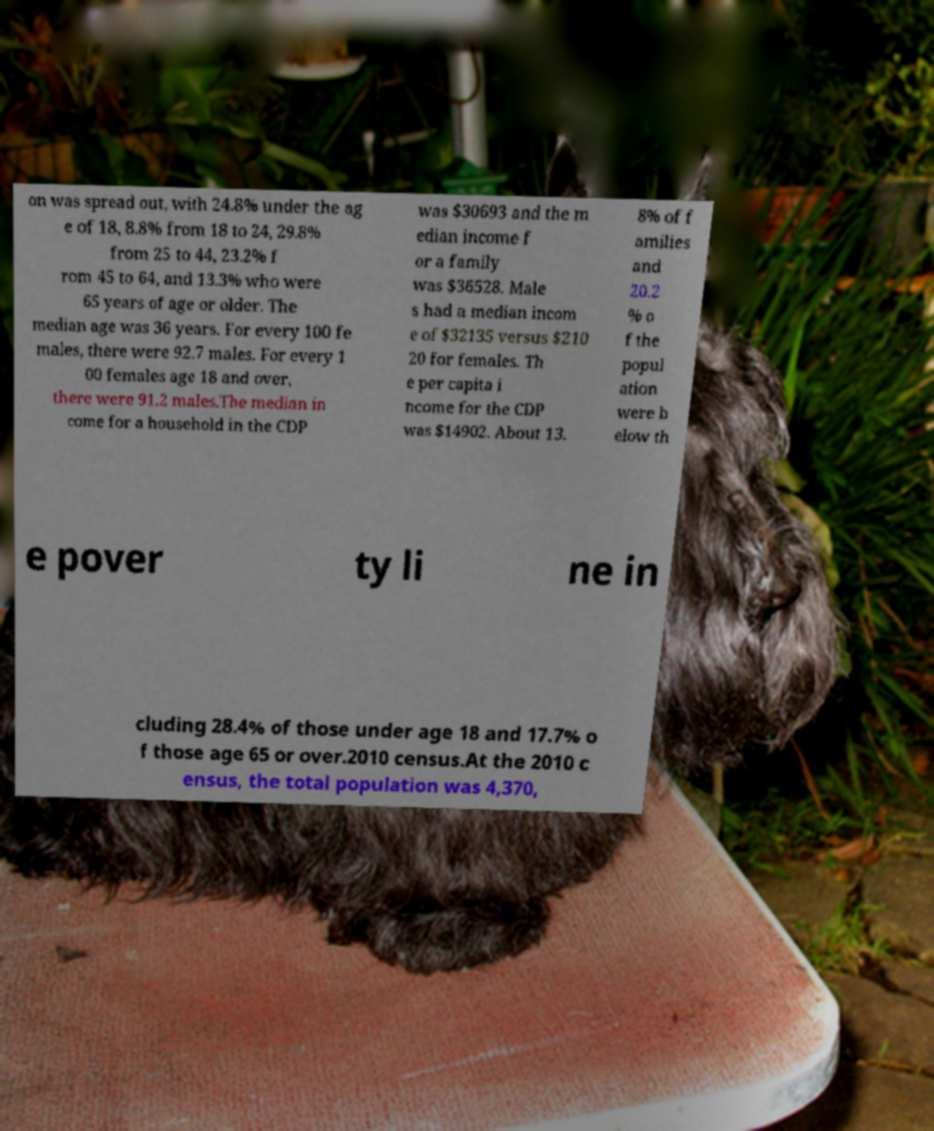Could you extract and type out the text from this image? on was spread out, with 24.8% under the ag e of 18, 8.8% from 18 to 24, 29.8% from 25 to 44, 23.2% f rom 45 to 64, and 13.3% who were 65 years of age or older. The median age was 36 years. For every 100 fe males, there were 92.7 males. For every 1 00 females age 18 and over, there were 91.2 males.The median in come for a household in the CDP was $30693 and the m edian income f or a family was $36528. Male s had a median incom e of $32135 versus $210 20 for females. Th e per capita i ncome for the CDP was $14902. About 13. 8% of f amilies and 20.2 % o f the popul ation were b elow th e pover ty li ne in cluding 28.4% of those under age 18 and 17.7% o f those age 65 or over.2010 census.At the 2010 c ensus, the total population was 4,370, 